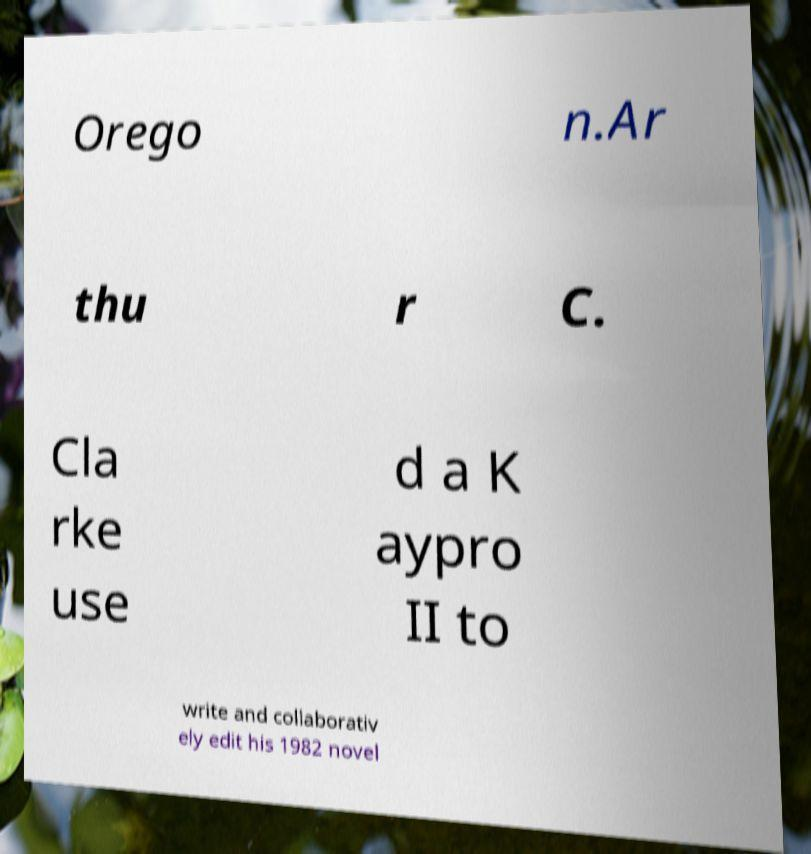Please read and relay the text visible in this image. What does it say? Orego n.Ar thu r C. Cla rke use d a K aypro II to write and collaborativ ely edit his 1982 novel 